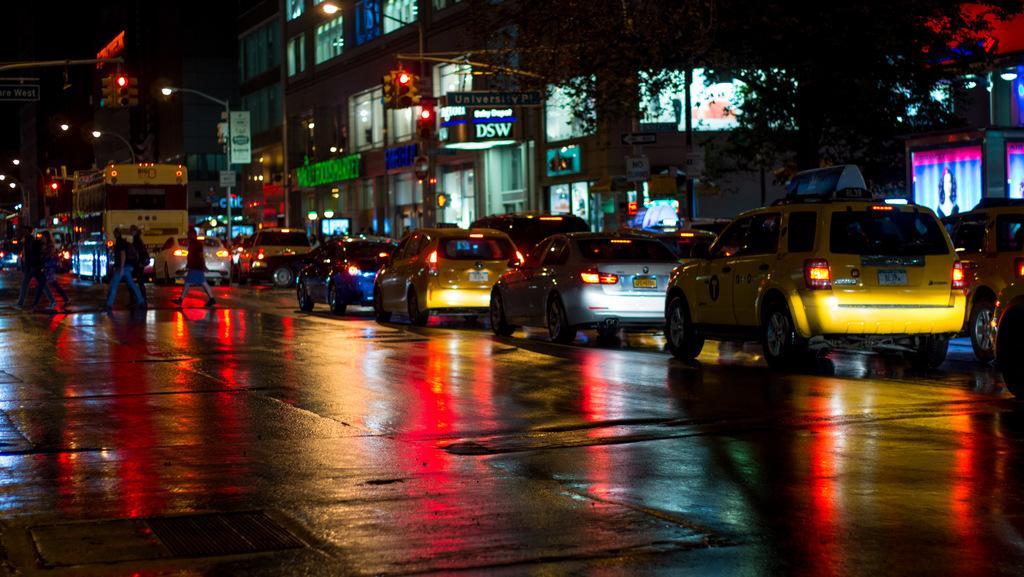In one or two sentences, can you explain what this image depicts? In this image we can see some buildings which consist of some text and screens on it, in front of it there are vehicles, lights, poles, traffic lights, posters and a group of people are walking. 